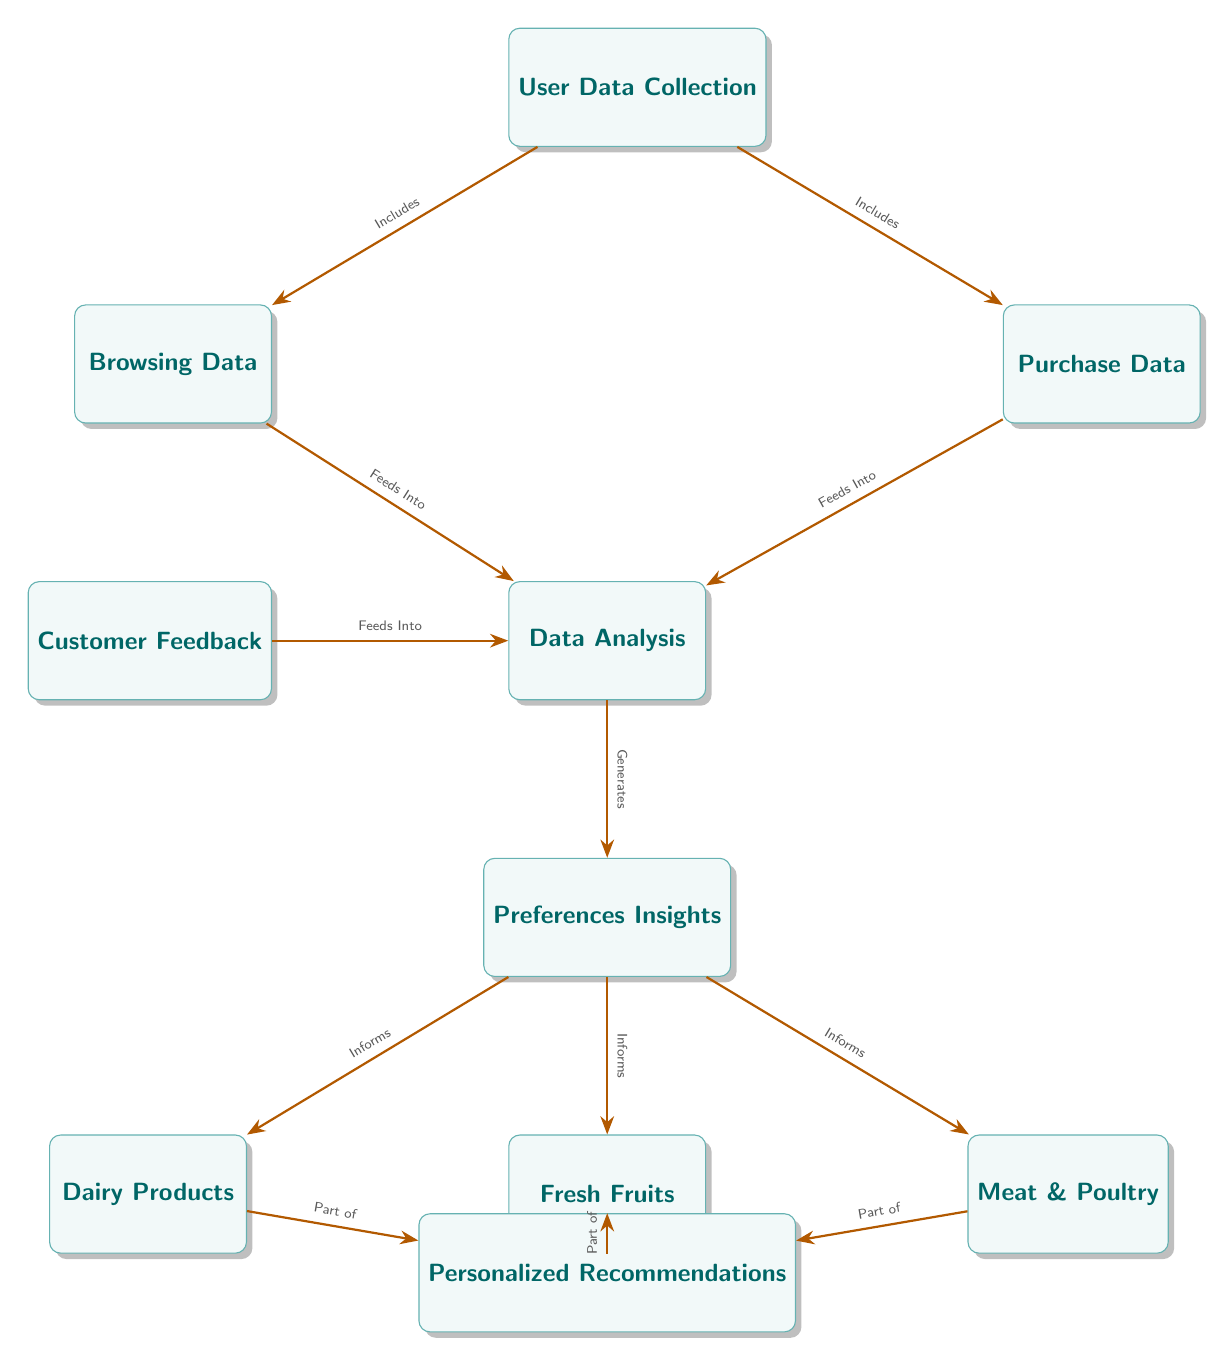What are the three main data sources? The diagram shows three main data sources: User Data Collection, Browsing Data, and Purchase Data. Each is indicated as a separate box in the diagram.
Answer: Browsing Data, Purchase Data How many types of food categories are informed by Preferences Insights? The diagram indicates that Preferences Insights informs three specific food categories: Dairy Products, Fresh Fruits, and Meat & Poultry. Each category is represented as an individual node branching from Preferences Insights.
Answer: Three What does Customer Feedback feed into? According to the diagram, Customer Feedback feeds into Data Analysis, which is a crucial part of the data processing flow. This connection is clearly indicated by the arrow leading from Customer Feedback to Data Analysis.
Answer: Data Analysis Which node generates Preferences Insights? In the diagram, Preferences Insights is generated by Data Analysis, as indicated by the arrow leading from Data Analysis to Preferences Insights. This shows that insights on preferences are derived from the analysis of the data.
Answer: Data Analysis What is the relationship between Preferences Insights and Personalized Recommendations? The diagram shows that Personalized Recommendations are part of multiple food categories informed by Preferences Insights, indicating that the insights directly contribute to the formation of recommendations.
Answer: Part of Explain how Data Analysis integrates information. Data Analysis integrates information from several nodes: it receives data from Browsing Data, Purchase Data, and Customer Feedback. This convergence of data sources is illustrated by arrows pointing toward Data Analysis, showing that it synthesizes this information for further processing.
Answer: Integrates data from multiple sources How does Data Analysis impact food category preferences? Data Analysis generates Preferences Insights, which then informs the food categories. This means that the analysis conducted impacts what recommendations are made for Dairy Products, Fresh Fruits, and Meat & Poultry based on consumer preferences and feedback.
Answer: Impacts food categories through insights What is the starting point of the data flow in the diagram? The starting point of the data flow is User Data Collection, which then branches out to Browsing Data and Purchase Data. This is the initial stage of collecting data that is essential for further analysis.
Answer: User Data Collection What type of diagram is used to represent the data flow within the food chain? The diagram used is a flowchart, which visually illustrates the flow of data and relationships between different entities in the food chain. The use of directional arrows and nodes reflects the flow of information clearly.
Answer: Flowchart 